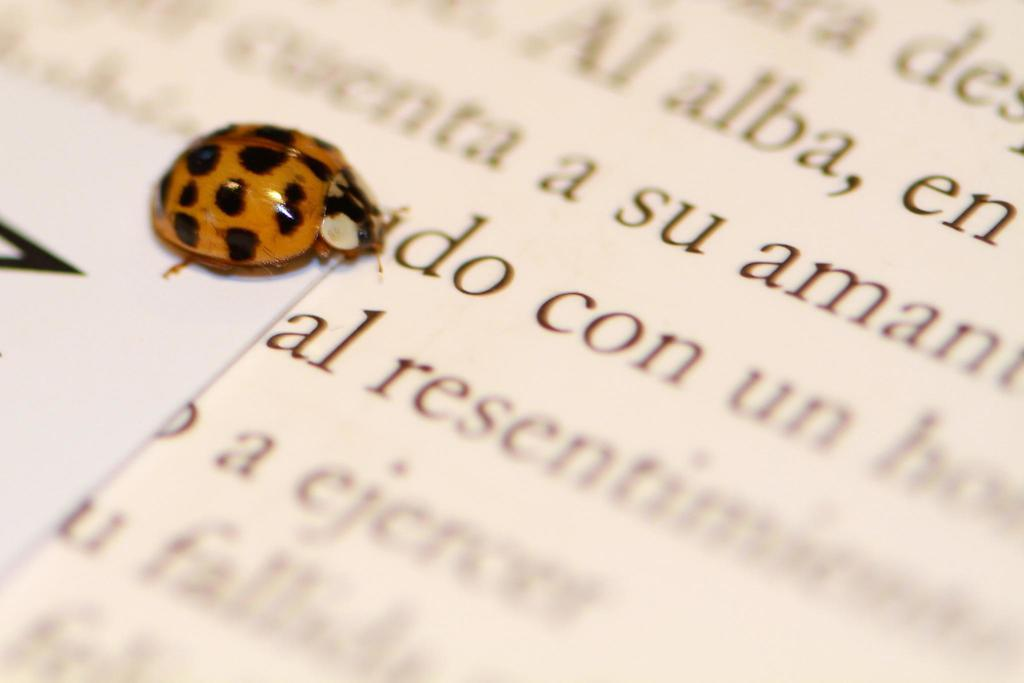What insect is present in the image? There is a ladybug in the image. What is the ladybug resting on? The ladybug is on papers. What type of food is the ladybug eating in the image? There is no food present in the image, and the ladybug is not shown eating anything. 